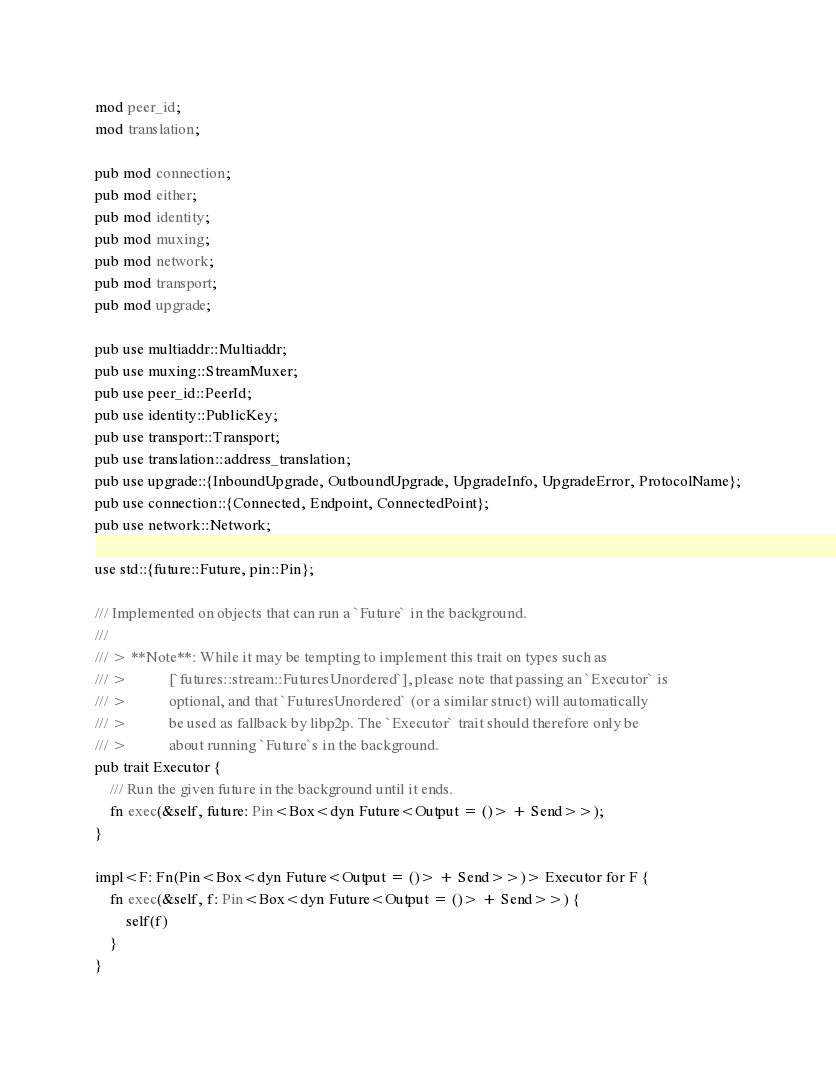<code> <loc_0><loc_0><loc_500><loc_500><_Rust_>
mod peer_id;
mod translation;

pub mod connection;
pub mod either;
pub mod identity;
pub mod muxing;
pub mod network;
pub mod transport;
pub mod upgrade;

pub use multiaddr::Multiaddr;
pub use muxing::StreamMuxer;
pub use peer_id::PeerId;
pub use identity::PublicKey;
pub use transport::Transport;
pub use translation::address_translation;
pub use upgrade::{InboundUpgrade, OutboundUpgrade, UpgradeInfo, UpgradeError, ProtocolName};
pub use connection::{Connected, Endpoint, ConnectedPoint};
pub use network::Network;

use std::{future::Future, pin::Pin};

/// Implemented on objects that can run a `Future` in the background.
///
/// > **Note**: While it may be tempting to implement this trait on types such as
/// >           [`futures::stream::FuturesUnordered`], please note that passing an `Executor` is
/// >           optional, and that `FuturesUnordered` (or a similar struct) will automatically
/// >           be used as fallback by libp2p. The `Executor` trait should therefore only be
/// >           about running `Future`s in the background.
pub trait Executor {
    /// Run the given future in the background until it ends.
    fn exec(&self, future: Pin<Box<dyn Future<Output = ()> + Send>>);
}

impl<F: Fn(Pin<Box<dyn Future<Output = ()> + Send>>)> Executor for F {
    fn exec(&self, f: Pin<Box<dyn Future<Output = ()> + Send>>) {
        self(f)
    }
}
</code> 